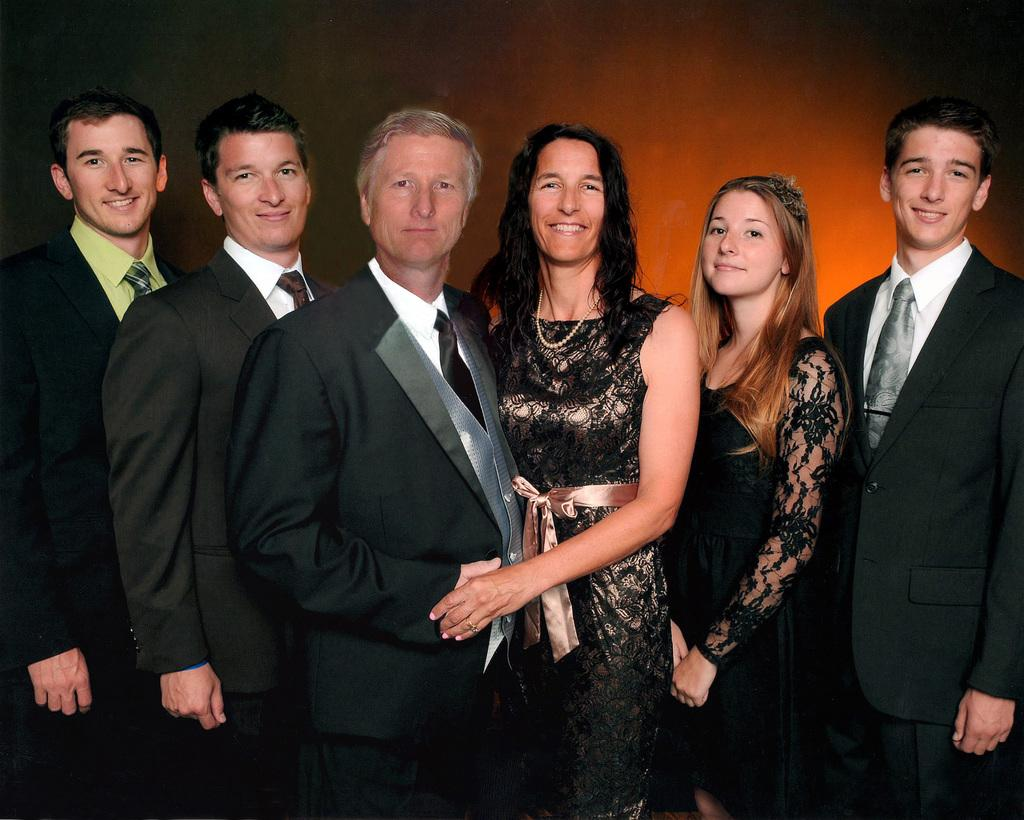How many people are present in the image? There are six people in the image, including two women and four men. What are the men wearing in the image? The men are wearing suits in the image. What color are the dresses worn by the women? The women are wearing black color dresses. What can be seen in the background of the image? There appears to be a wall in the background of the image. What type of profit can be seen in the image? There is no mention of profit in the image; it features two women and four men in specific attire. Can you tell me how many stalks of celery are present in the image? There is no celery present in the image. 